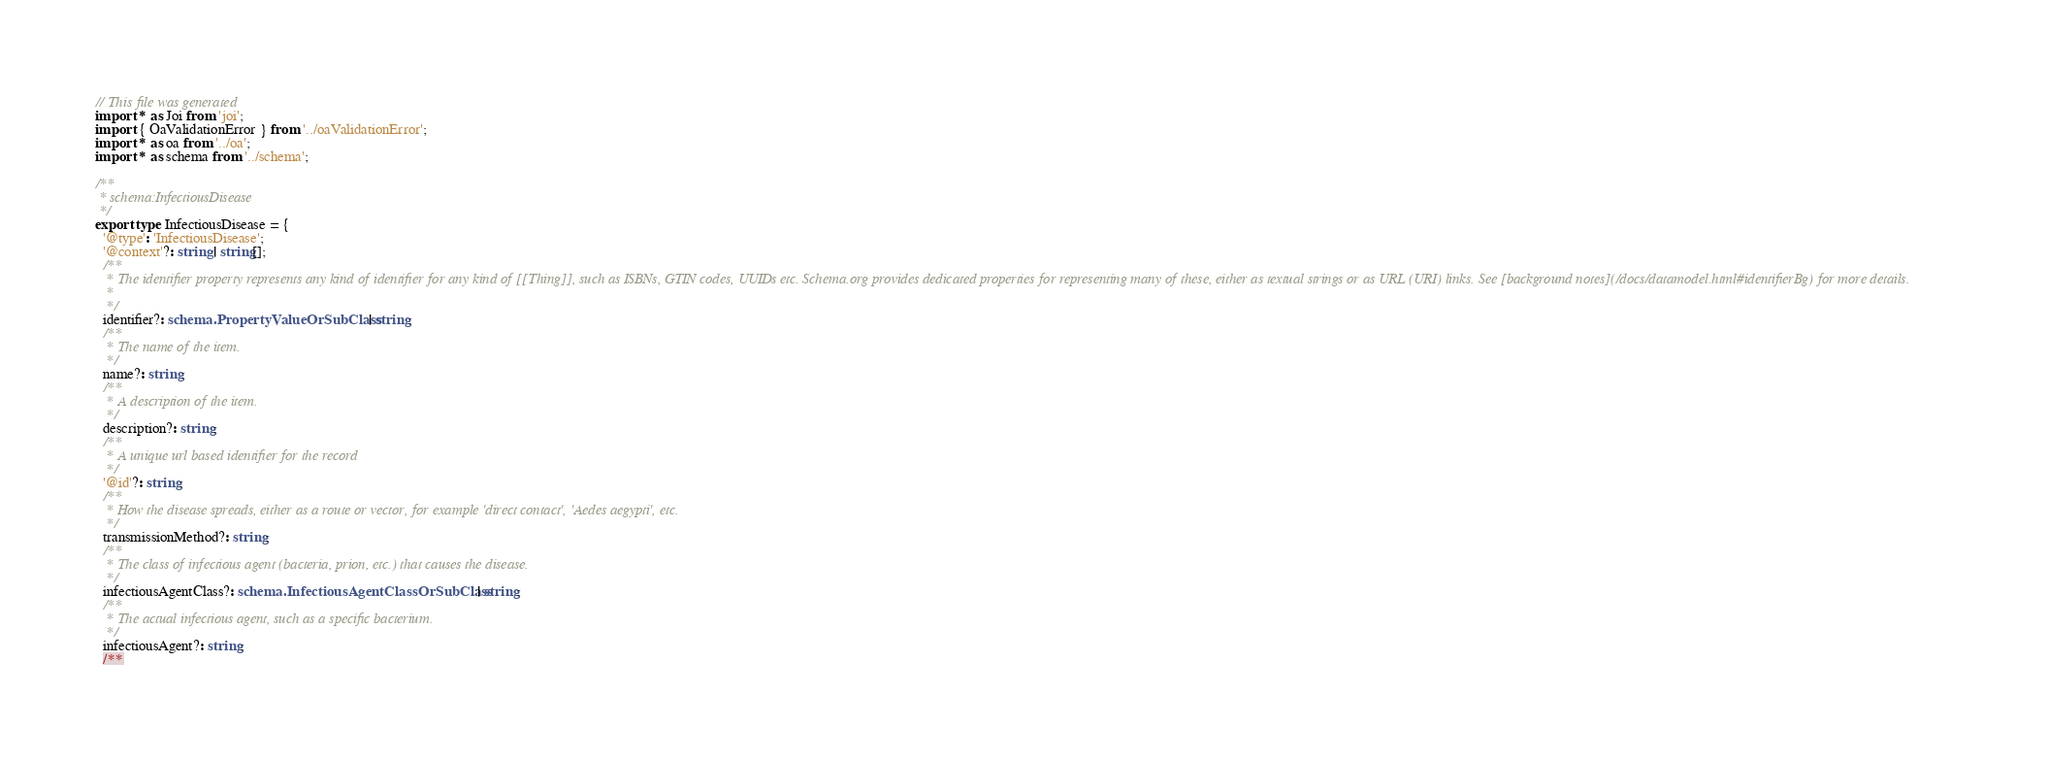<code> <loc_0><loc_0><loc_500><loc_500><_TypeScript_>// This file was generated
import * as Joi from 'joi';
import { OaValidationError } from '../oaValidationError';
import * as oa from '../oa';
import * as schema from '../schema';

/**
 * schema:InfectiousDisease
 */
export type InfectiousDisease = {
  '@type': 'InfectiousDisease';
  '@context'?: string | string[];
  /**
   * The identifier property represents any kind of identifier for any kind of [[Thing]], such as ISBNs, GTIN codes, UUIDs etc. Schema.org provides dedicated properties for representing many of these, either as textual strings or as URL (URI) links. See [background notes](/docs/datamodel.html#identifierBg) for more details.
   *         
   */
  identifier?: schema.PropertyValueOrSubClass | string;
  /**
   * The name of the item.
   */
  name?: string;
  /**
   * A description of the item.
   */
  description?: string;
  /**
   * A unique url based identifier for the record
   */
  '@id'?: string;
  /**
   * How the disease spreads, either as a route or vector, for example 'direct contact', 'Aedes aegypti', etc.
   */
  transmissionMethod?: string;
  /**
   * The class of infectious agent (bacteria, prion, etc.) that causes the disease.
   */
  infectiousAgentClass?: schema.InfectiousAgentClassOrSubClass | string;
  /**
   * The actual infectious agent, such as a specific bacterium.
   */
  infectiousAgent?: string;
  /**</code> 